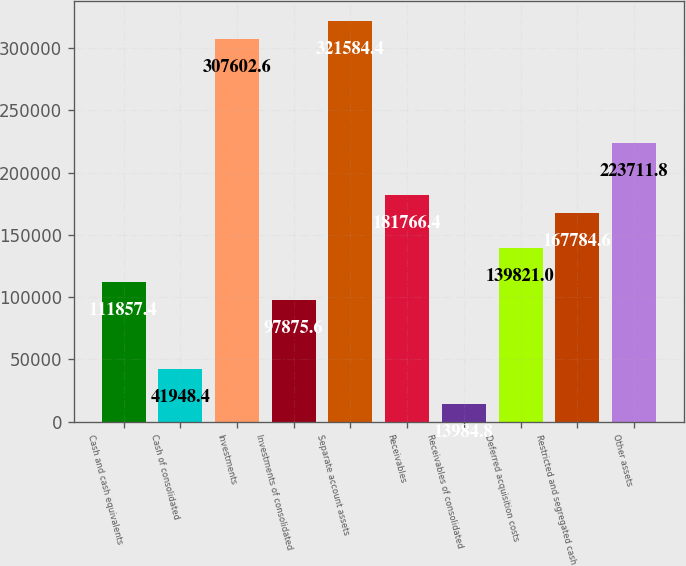Convert chart to OTSL. <chart><loc_0><loc_0><loc_500><loc_500><bar_chart><fcel>Cash and cash equivalents<fcel>Cash of consolidated<fcel>Investments<fcel>Investments of consolidated<fcel>Separate account assets<fcel>Receivables<fcel>Receivables of consolidated<fcel>Deferred acquisition costs<fcel>Restricted and segregated cash<fcel>Other assets<nl><fcel>111857<fcel>41948.4<fcel>307603<fcel>97875.6<fcel>321584<fcel>181766<fcel>13984.8<fcel>139821<fcel>167785<fcel>223712<nl></chart> 